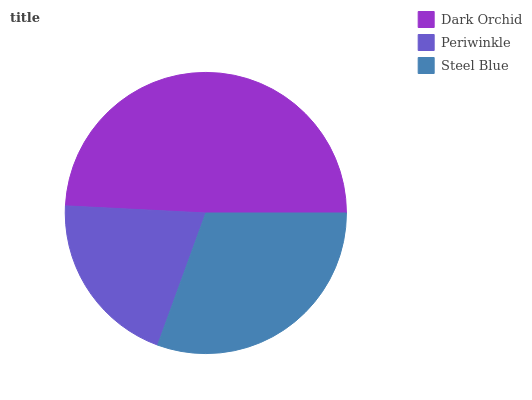Is Periwinkle the minimum?
Answer yes or no. Yes. Is Dark Orchid the maximum?
Answer yes or no. Yes. Is Steel Blue the minimum?
Answer yes or no. No. Is Steel Blue the maximum?
Answer yes or no. No. Is Steel Blue greater than Periwinkle?
Answer yes or no. Yes. Is Periwinkle less than Steel Blue?
Answer yes or no. Yes. Is Periwinkle greater than Steel Blue?
Answer yes or no. No. Is Steel Blue less than Periwinkle?
Answer yes or no. No. Is Steel Blue the high median?
Answer yes or no. Yes. Is Steel Blue the low median?
Answer yes or no. Yes. Is Dark Orchid the high median?
Answer yes or no. No. Is Periwinkle the low median?
Answer yes or no. No. 